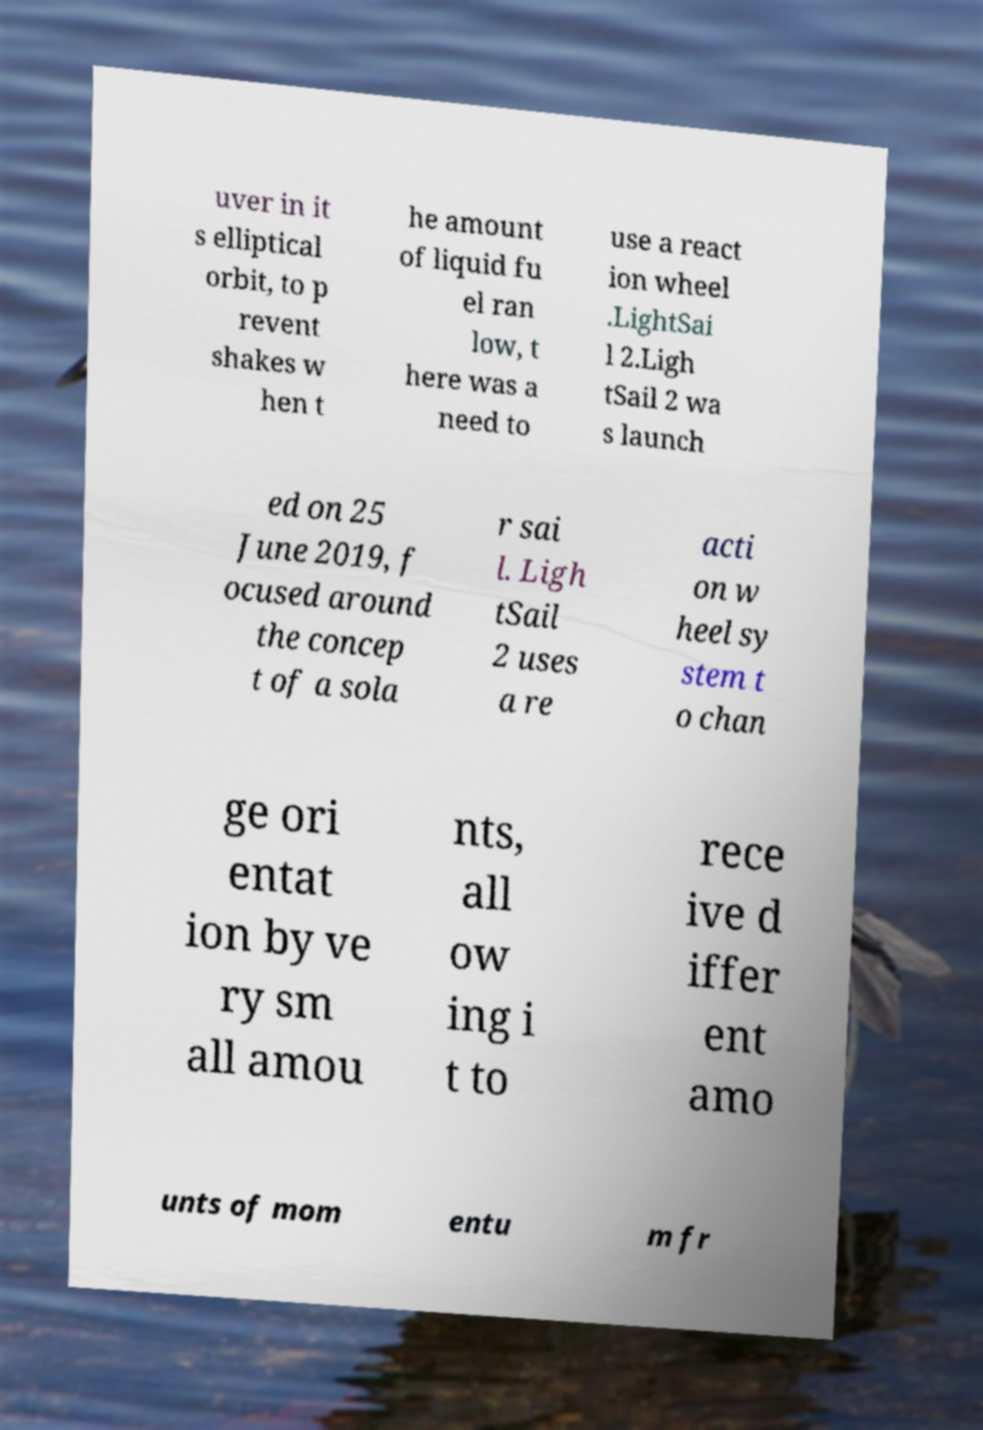Could you assist in decoding the text presented in this image and type it out clearly? uver in it s elliptical orbit, to p revent shakes w hen t he amount of liquid fu el ran low, t here was a need to use a react ion wheel .LightSai l 2.Ligh tSail 2 wa s launch ed on 25 June 2019, f ocused around the concep t of a sola r sai l. Ligh tSail 2 uses a re acti on w heel sy stem t o chan ge ori entat ion by ve ry sm all amou nts, all ow ing i t to rece ive d iffer ent amo unts of mom entu m fr 